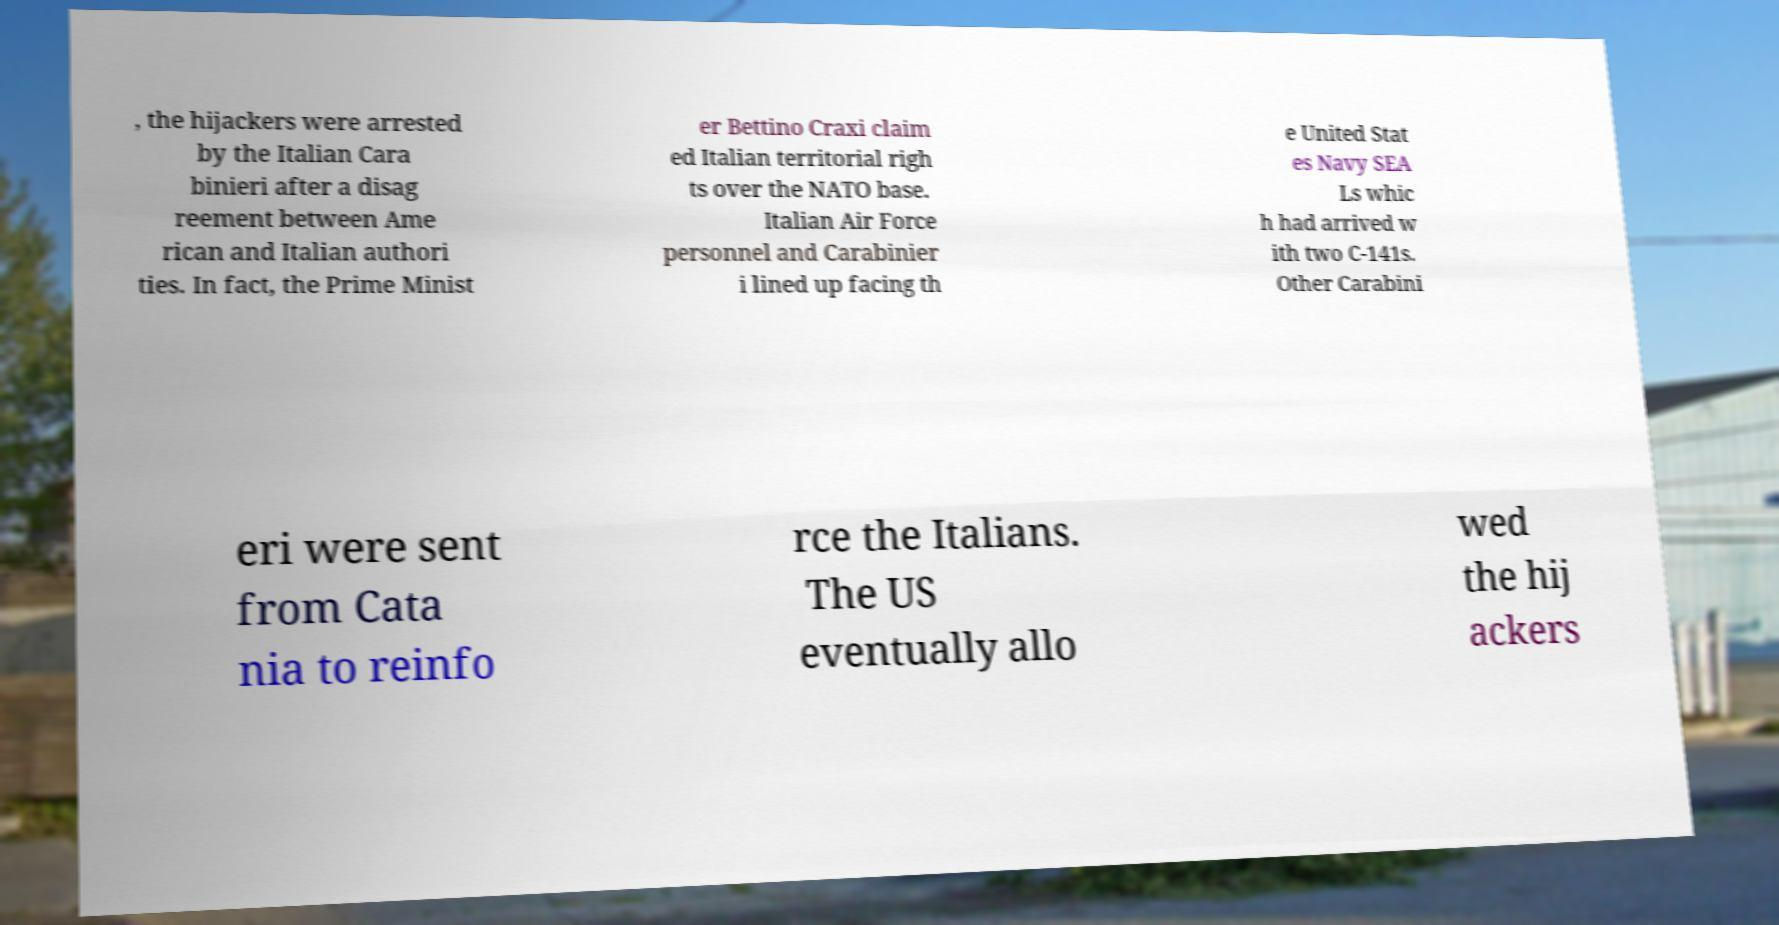Please identify and transcribe the text found in this image. , the hijackers were arrested by the Italian Cara binieri after a disag reement between Ame rican and Italian authori ties. In fact, the Prime Minist er Bettino Craxi claim ed Italian territorial righ ts over the NATO base. Italian Air Force personnel and Carabinier i lined up facing th e United Stat es Navy SEA Ls whic h had arrived w ith two C-141s. Other Carabini eri were sent from Cata nia to reinfo rce the Italians. The US eventually allo wed the hij ackers 